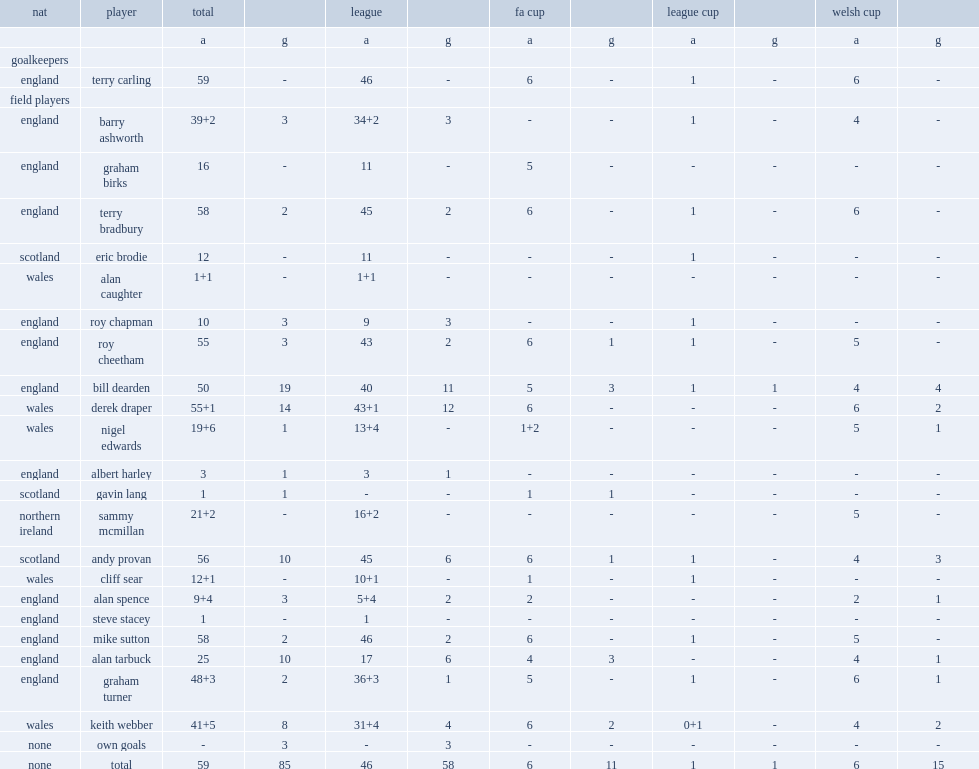List the matches that chester f.c. participated in. League fa cup league cup welsh cup. 